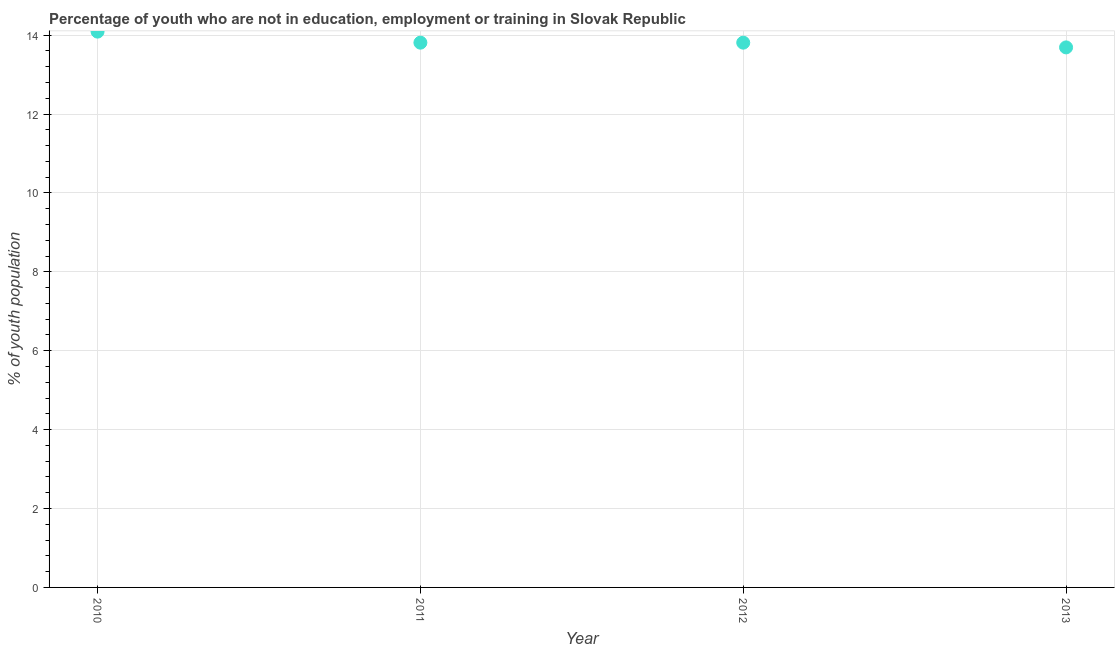What is the unemployed youth population in 2012?
Provide a succinct answer. 13.81. Across all years, what is the maximum unemployed youth population?
Make the answer very short. 14.09. Across all years, what is the minimum unemployed youth population?
Your answer should be compact. 13.69. In which year was the unemployed youth population maximum?
Offer a very short reply. 2010. What is the sum of the unemployed youth population?
Your answer should be very brief. 55.4. What is the difference between the unemployed youth population in 2011 and 2012?
Your answer should be compact. 0. What is the average unemployed youth population per year?
Keep it short and to the point. 13.85. What is the median unemployed youth population?
Provide a short and direct response. 13.81. Do a majority of the years between 2011 and 2010 (inclusive) have unemployed youth population greater than 7.6 %?
Offer a very short reply. No. What is the ratio of the unemployed youth population in 2012 to that in 2013?
Your answer should be very brief. 1.01. Is the unemployed youth population in 2010 less than that in 2013?
Offer a very short reply. No. What is the difference between the highest and the second highest unemployed youth population?
Ensure brevity in your answer.  0.28. What is the difference between the highest and the lowest unemployed youth population?
Your answer should be very brief. 0.4. How many dotlines are there?
Make the answer very short. 1. Are the values on the major ticks of Y-axis written in scientific E-notation?
Ensure brevity in your answer.  No. What is the title of the graph?
Provide a succinct answer. Percentage of youth who are not in education, employment or training in Slovak Republic. What is the label or title of the X-axis?
Offer a very short reply. Year. What is the label or title of the Y-axis?
Make the answer very short. % of youth population. What is the % of youth population in 2010?
Give a very brief answer. 14.09. What is the % of youth population in 2011?
Ensure brevity in your answer.  13.81. What is the % of youth population in 2012?
Offer a very short reply. 13.81. What is the % of youth population in 2013?
Keep it short and to the point. 13.69. What is the difference between the % of youth population in 2010 and 2011?
Keep it short and to the point. 0.28. What is the difference between the % of youth population in 2010 and 2012?
Your response must be concise. 0.28. What is the difference between the % of youth population in 2011 and 2012?
Give a very brief answer. 0. What is the difference between the % of youth population in 2011 and 2013?
Offer a terse response. 0.12. What is the difference between the % of youth population in 2012 and 2013?
Provide a succinct answer. 0.12. What is the ratio of the % of youth population in 2010 to that in 2013?
Provide a short and direct response. 1.03. What is the ratio of the % of youth population in 2011 to that in 2012?
Provide a short and direct response. 1. What is the ratio of the % of youth population in 2011 to that in 2013?
Give a very brief answer. 1.01. What is the ratio of the % of youth population in 2012 to that in 2013?
Provide a short and direct response. 1.01. 